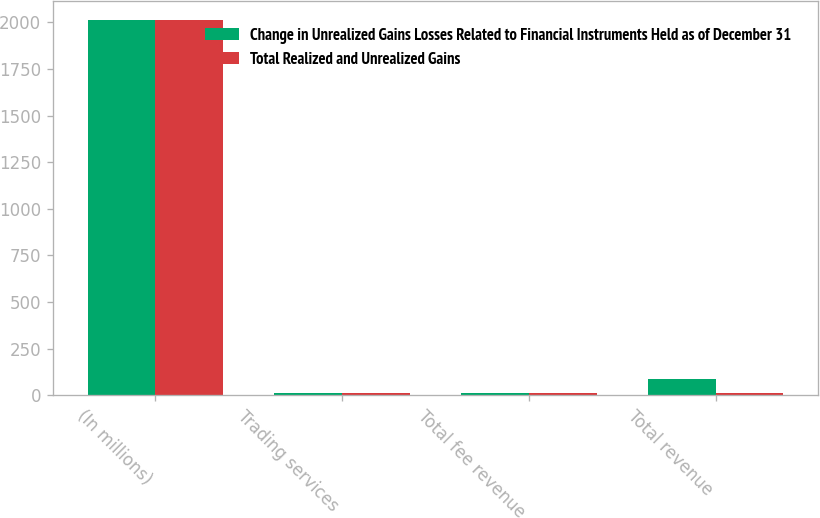Convert chart to OTSL. <chart><loc_0><loc_0><loc_500><loc_500><stacked_bar_chart><ecel><fcel>(In millions)<fcel>Trading services<fcel>Total fee revenue<fcel>Total revenue<nl><fcel>Change in Unrealized Gains Losses Related to Financial Instruments Held as of December 31<fcel>2014<fcel>11<fcel>11<fcel>85<nl><fcel>Total Realized and Unrealized Gains<fcel>2014<fcel>9<fcel>9<fcel>9<nl></chart> 